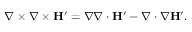<formula> <loc_0><loc_0><loc_500><loc_500>\nabla \times \nabla \times H ^ { \prime } = \nabla \nabla \cdot H ^ { \prime } - \nabla \cdot \nabla H ^ { \prime } .</formula> 